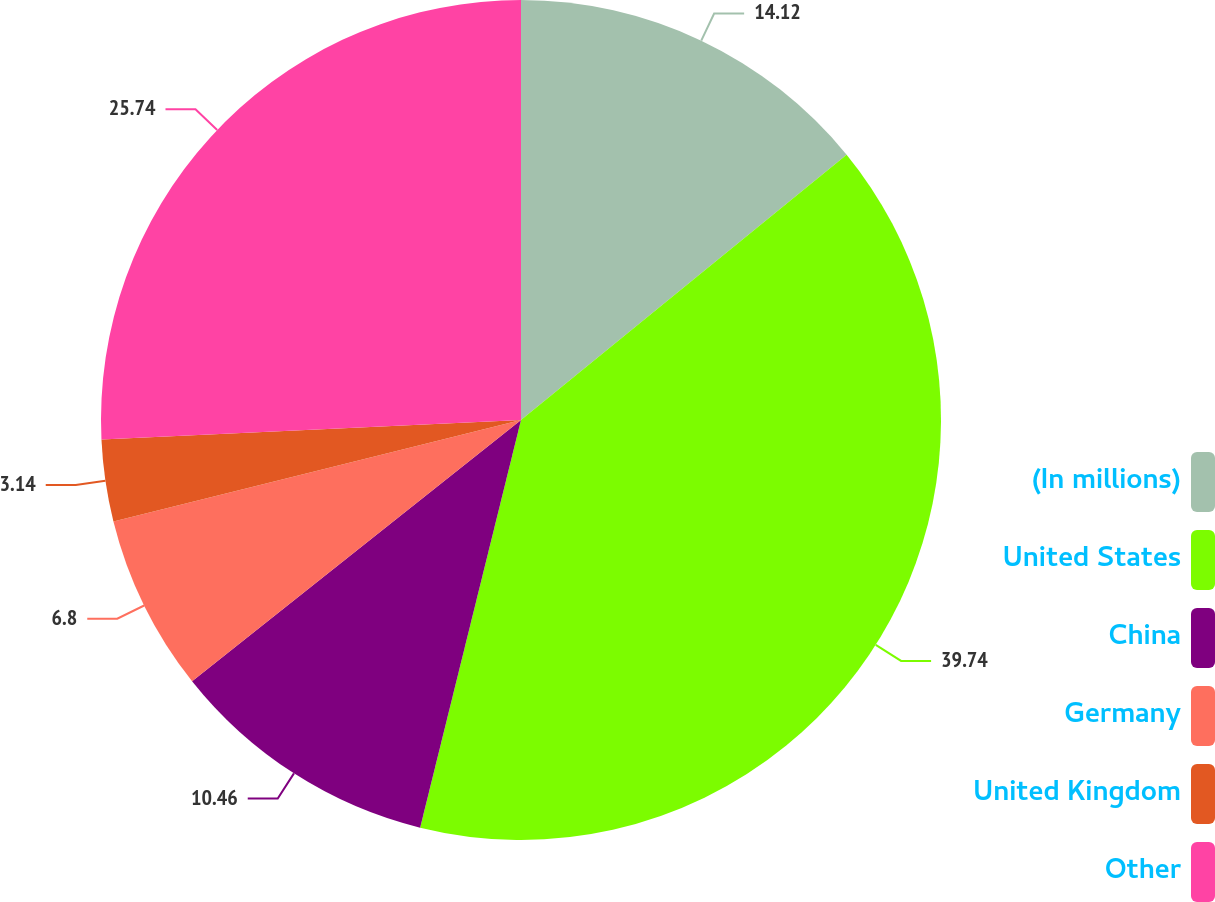Convert chart. <chart><loc_0><loc_0><loc_500><loc_500><pie_chart><fcel>(In millions)<fcel>United States<fcel>China<fcel>Germany<fcel>United Kingdom<fcel>Other<nl><fcel>14.12%<fcel>39.74%<fcel>10.46%<fcel>6.8%<fcel>3.14%<fcel>25.74%<nl></chart> 